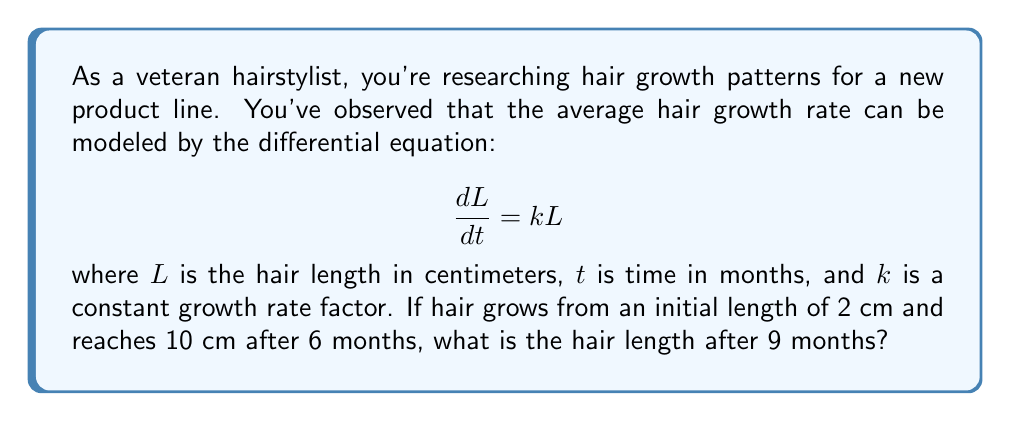Show me your answer to this math problem. To solve this problem, we'll follow these steps:

1) The given differential equation is a first-order linear differential equation. Its general solution is:

   $$L(t) = Ce^{kt}$$

   where $C$ is a constant determined by the initial condition.

2) We're given two conditions:
   - Initial length: $L(0) = 2$ cm
   - After 6 months: $L(6) = 10$ cm

3) Using the initial condition:
   
   $$2 = Ce^{k(0)} = C$$

   So our solution is of the form: $L(t) = 2e^{kt}$

4) Now we can use the second condition to find $k$:

   $$10 = 2e^{k(6)}$$
   $$5 = e^{6k}$$
   $$\ln(5) = 6k$$
   $$k = \frac{\ln(5)}{6} \approx 0.2699$$

5) Now that we have $k$, our complete solution is:

   $$L(t) = 2e^{0.2699t}$$

6) To find the length after 9 months, we simply plug in $t=9$:

   $$L(9) = 2e^{0.2699(9)} \approx 14.48$$

Therefore, after 9 months, the hair length will be approximately 14.48 cm.
Answer: $14.48$ cm 